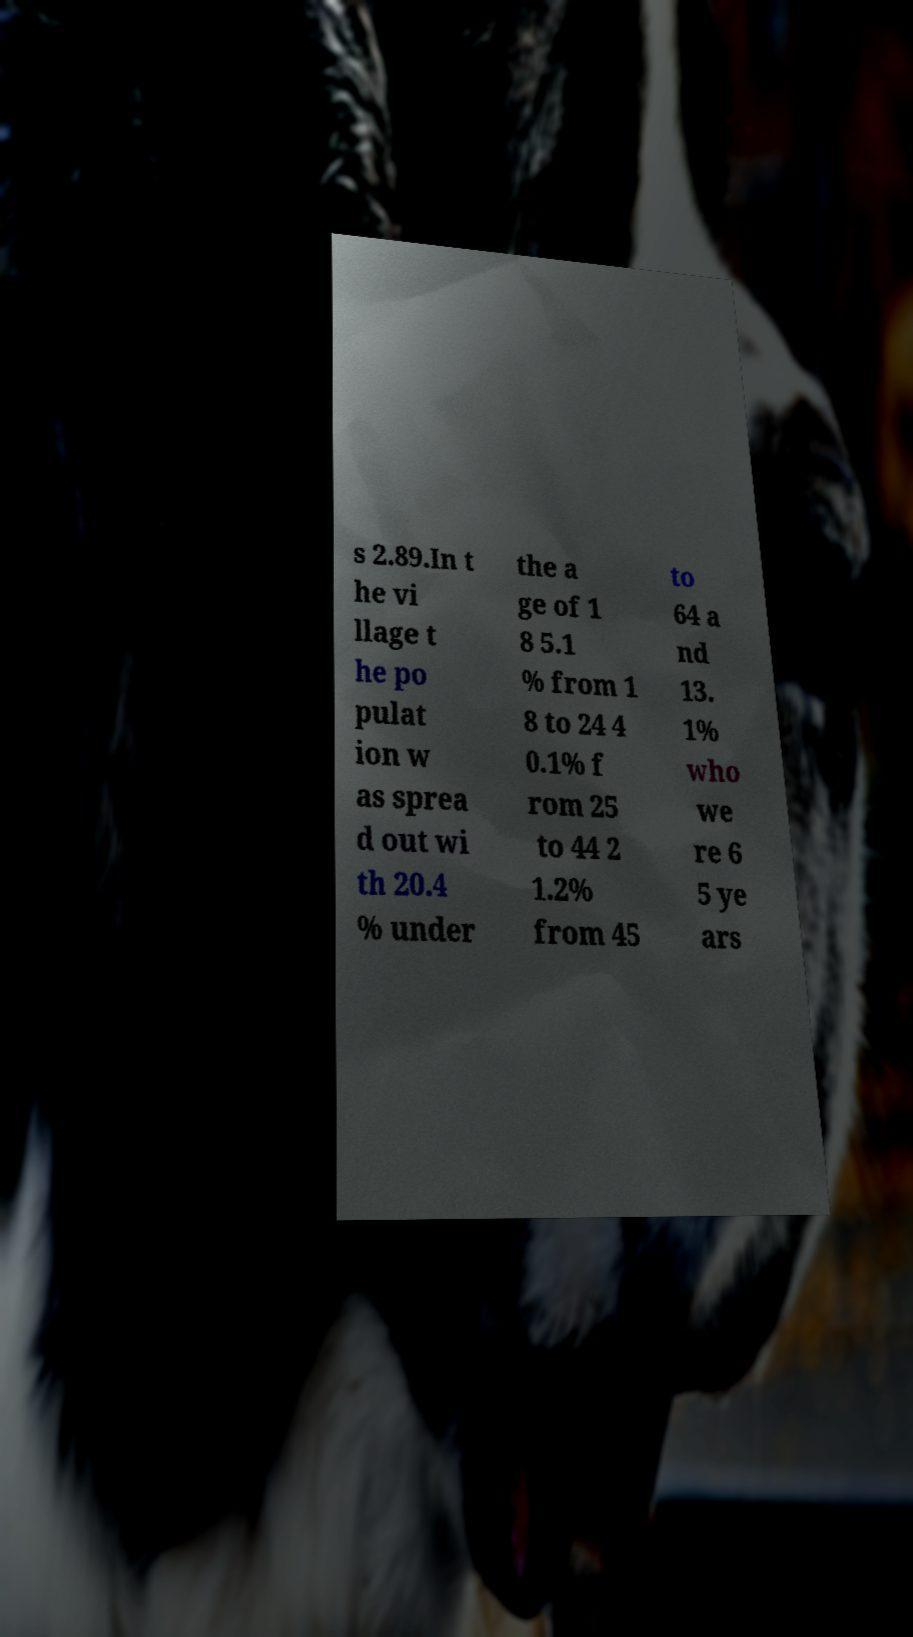Can you accurately transcribe the text from the provided image for me? s 2.89.In t he vi llage t he po pulat ion w as sprea d out wi th 20.4 % under the a ge of 1 8 5.1 % from 1 8 to 24 4 0.1% f rom 25 to 44 2 1.2% from 45 to 64 a nd 13. 1% who we re 6 5 ye ars 